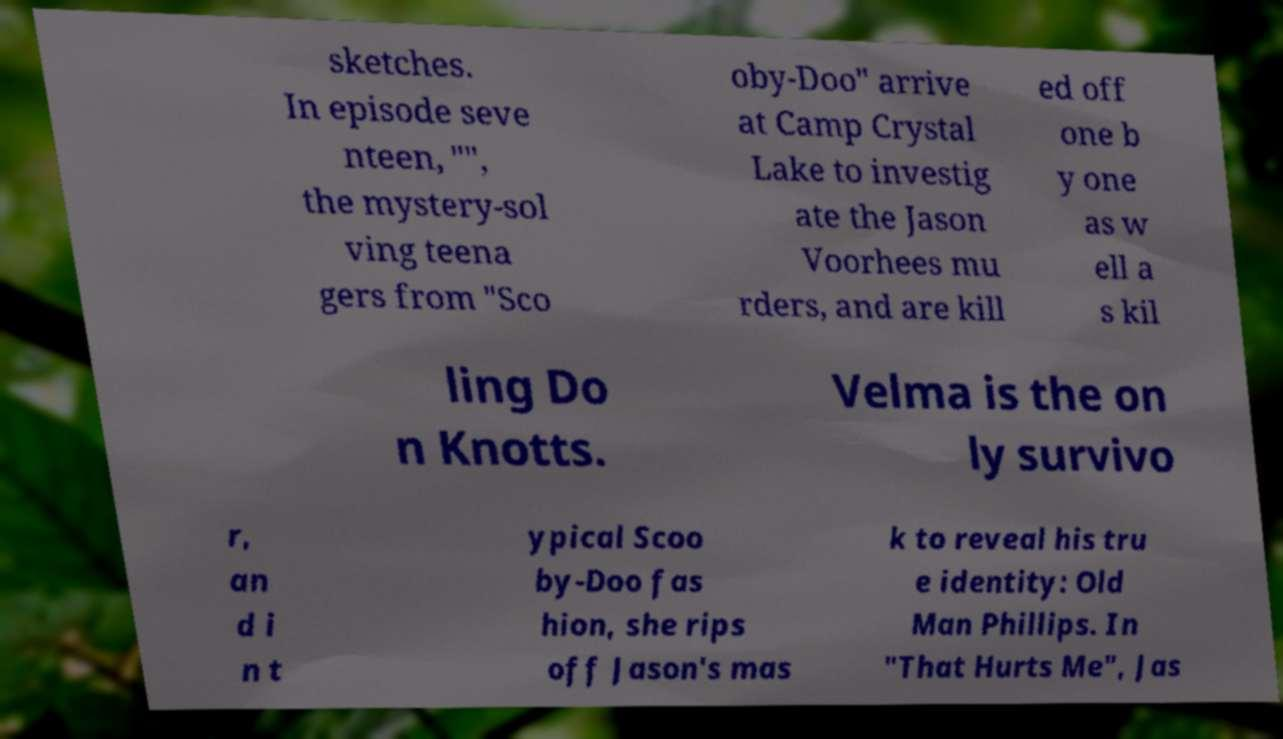For documentation purposes, I need the text within this image transcribed. Could you provide that? sketches. In episode seve nteen, "", the mystery-sol ving teena gers from "Sco oby-Doo" arrive at Camp Crystal Lake to investig ate the Jason Voorhees mu rders, and are kill ed off one b y one as w ell a s kil ling Do n Knotts. Velma is the on ly survivo r, an d i n t ypical Scoo by-Doo fas hion, she rips off Jason's mas k to reveal his tru e identity: Old Man Phillips. In "That Hurts Me", Jas 